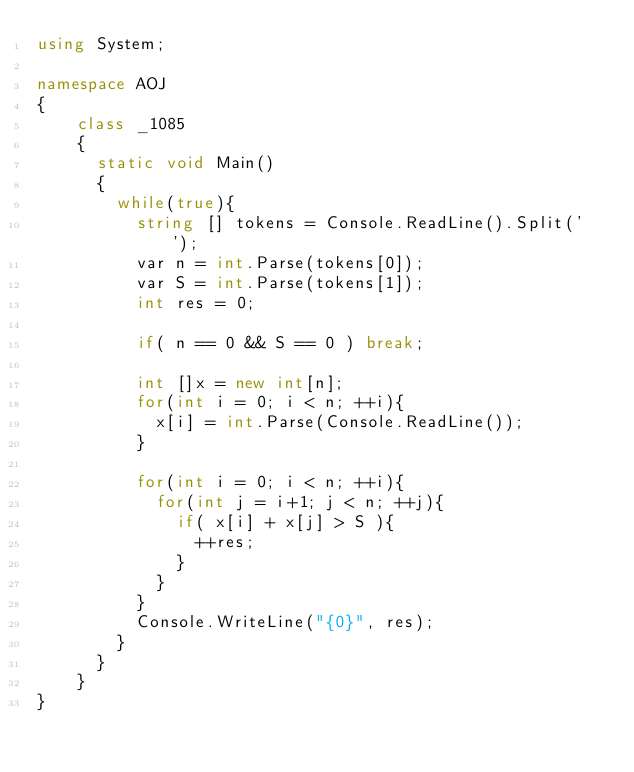Convert code to text. <code><loc_0><loc_0><loc_500><loc_500><_C#_>using System;

namespace AOJ
{
    class _1085
    {
	    static void Main()
	    {
		    while(true){
			    string [] tokens = Console.ReadLine().Split(' ');
			    var n = int.Parse(tokens[0]);
			    var S = int.Parse(tokens[1]);
			    int res = 0;
			
			    if( n == 0 && S == 0 ) break;
			
			    int []x = new int[n];
			    for(int i = 0; i < n; ++i){
				    x[i] = int.Parse(Console.ReadLine());
			    }
			
			    for(int i = 0; i < n; ++i){
				    for(int j = i+1; j < n; ++j){
					    if( x[i] + x[j] > S ){
						    ++res;
					    }
				    }
			    }
			    Console.WriteLine("{0}", res);
		    }
	    }
    }
}</code> 